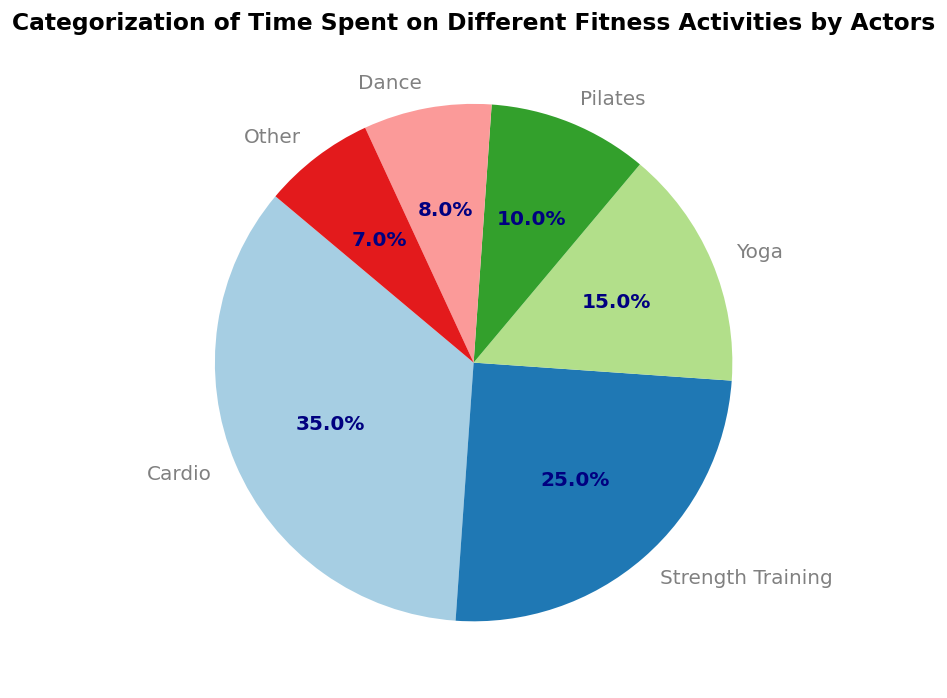What activity takes up the largest percentage of time? The largest segment of the pie chart represents the activity that takes up the most time. By observing which segment is the biggest and its label, we can see that 'Cardio' occupies the largest portion.
Answer: Cardio How much more percentage of time is spent on Cardio than on Pilates? To determine the difference, subtract the percentage for Pilates from the percentage for Cardio: 35% - 10%.
Answer: 25% Which activities together make up half of the total time spent? Identify the combination of activities whose sum equals 50%. Adding the largest percentages first, Cardio (35%) + Strength Training (25%) equals 60%, so move to the next smaller combination: Cardio (35%) + Yoga (15%) equals 50%.
Answer: Cardio and Yoga Rank the activities from most to least in terms of time spent. To rank the activities, list them in order of their percentages from highest to lowest: Cardio (35%), Strength Training (25%), Yoga (15%), Pilates (10%), Dance (8%), Other (7%).
Answer: Cardio, Strength Training, Yoga, Pilates, Dance, Other What fraction of the time is spent on Dance and Other combined? Add the percentages for Dance and Other and convert to a fraction: 8% + 7% = 15%, which can be expressed as a fraction of the whole (100%): 15/100 or simplified as 3/20.
Answer: 3/20 Is the time spent on Yoga greater than the time spent on Dance and Other combined? Compare the percentage for Yoga (15%) with the combined percentage of Dance (8%) and Other (7%): 15% vs. 15%. Since they are equal, the answer is no; they are the same.
Answer: No Which segment of the pie chart is visually the smallest, and what activity does it represent? By observing the pie chart, the smallest wedge can be identified by its size. The smallest segment is labeled 'Other.'
Answer: Other 